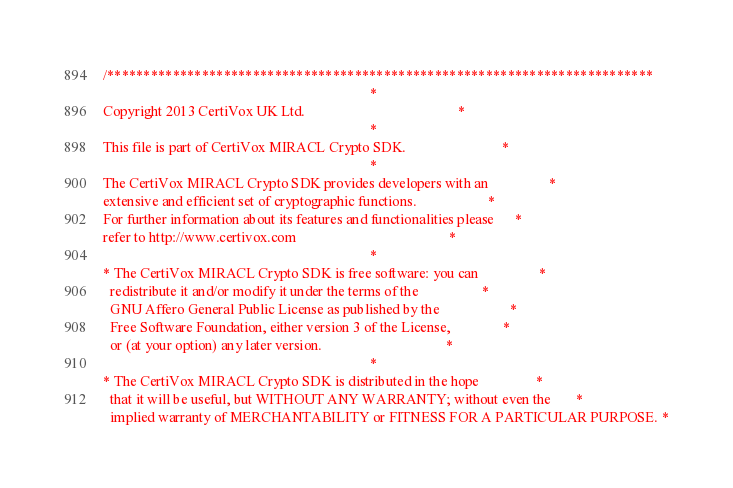<code> <loc_0><loc_0><loc_500><loc_500><_C++_>
/***************************************************************************
                                                                           *
Copyright 2013 CertiVox UK Ltd.                                           *
                                                                           *
This file is part of CertiVox MIRACL Crypto SDK.                           *
                                                                           *
The CertiVox MIRACL Crypto SDK provides developers with an                 *
extensive and efficient set of cryptographic functions.                    *
For further information about its features and functionalities please      *
refer to http://www.certivox.com                                           *
                                                                           *
* The CertiVox MIRACL Crypto SDK is free software: you can                 *
  redistribute it and/or modify it under the terms of the                  *
  GNU Affero General Public License as published by the                    *
  Free Software Foundation, either version 3 of the License,               *
  or (at your option) any later version.                                   *
                                                                           *
* The CertiVox MIRACL Crypto SDK is distributed in the hope                *
  that it will be useful, but WITHOUT ANY WARRANTY; without even the       *
  implied warranty of MERCHANTABILITY or FITNESS FOR A PARTICULAR PURPOSE. *</code> 